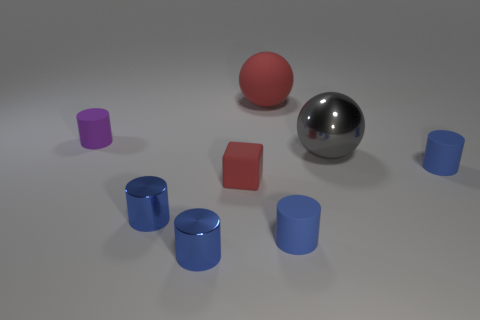Is there anything else that is the same shape as the tiny red object?
Make the answer very short. No. There is a matte thing that is behind the tiny rubber cylinder that is to the left of the tiny matte cylinder that is in front of the tiny red cube; what is its shape?
Ensure brevity in your answer.  Sphere. How many objects are matte things that are behind the gray metal ball or small blue cylinders that are on the left side of the gray ball?
Keep it short and to the point. 5. Does the purple thing have the same size as the red object in front of the gray shiny ball?
Ensure brevity in your answer.  Yes. Does the tiny thing behind the gray shiny sphere have the same material as the large gray sphere that is in front of the purple cylinder?
Ensure brevity in your answer.  No. Are there the same number of purple matte cylinders that are in front of the small purple rubber cylinder and large gray shiny things in front of the matte sphere?
Your answer should be compact. No. What number of matte spheres have the same color as the rubber block?
Provide a short and direct response. 1. There is a object that is the same color as the cube; what is its material?
Provide a succinct answer. Rubber. What number of matte things are gray balls or yellow objects?
Ensure brevity in your answer.  0. Do the small matte thing behind the large gray shiny thing and the red thing that is on the left side of the large red matte sphere have the same shape?
Make the answer very short. No. 